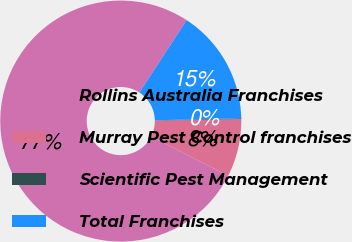Convert chart. <chart><loc_0><loc_0><loc_500><loc_500><pie_chart><fcel>Rollins Australia Franchises<fcel>Murray Pest Control franchises<fcel>Scientific Pest Management<fcel>Total Franchises<nl><fcel>76.69%<fcel>7.77%<fcel>0.11%<fcel>15.43%<nl></chart> 